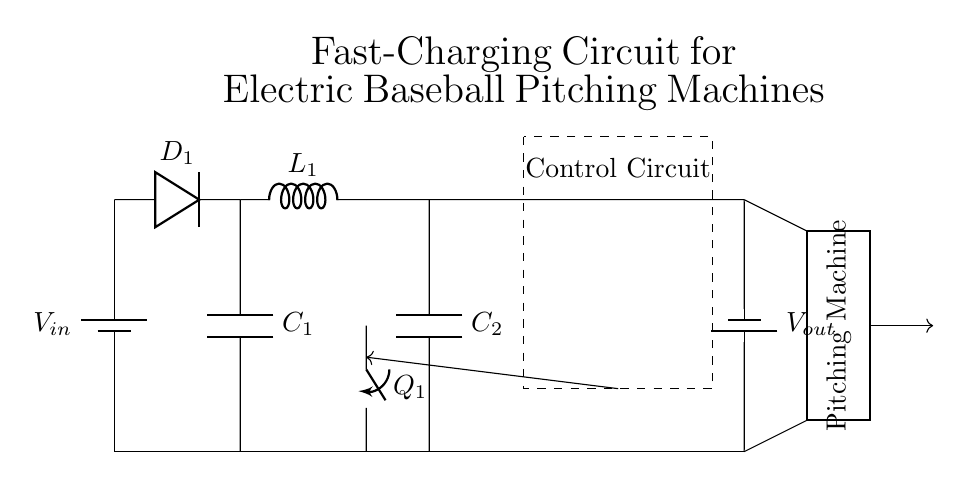What type of circuit is this? This is a fast-charging circuit which specifically includes a power supply, rectifier, buck converter, control circuit, and output for charging a baseball pitching machine.
Answer: Fast-charging circuit What component is labeled as D1? D1 is a diode which allows current to flow in one direction, thereby rectifying the AC from the power supply to DC.
Answer: Diode What is the purpose of the inductor L1? L1 is part of the buck converter, which helps in stepping down the voltage and storing energy. It also works in conjunction with the capacitor to smooth the output voltage.
Answer: Energy storage What is the voltage at Vout? Vout is the output voltage that results from the voltage reduction performed by the buck converter, this can be determined by considering the specifications of the circuit.
Answer: Not specified How many capacitors are in the circuit? The circuit has two capacitors labeled C1 and C2, used for filtering and energy storage.
Answer: Two What component controls the switching in the circuit? The component labeled Q1 is a switch that controls the flow of current in the buck converter, influencing when the output is charged.
Answer: Switch What does the dashed rectangle represent in the circuit? The dashed rectangle indicates the area containing the control circuit, which manages the operation of the entire charging process.
Answer: Control circuit 